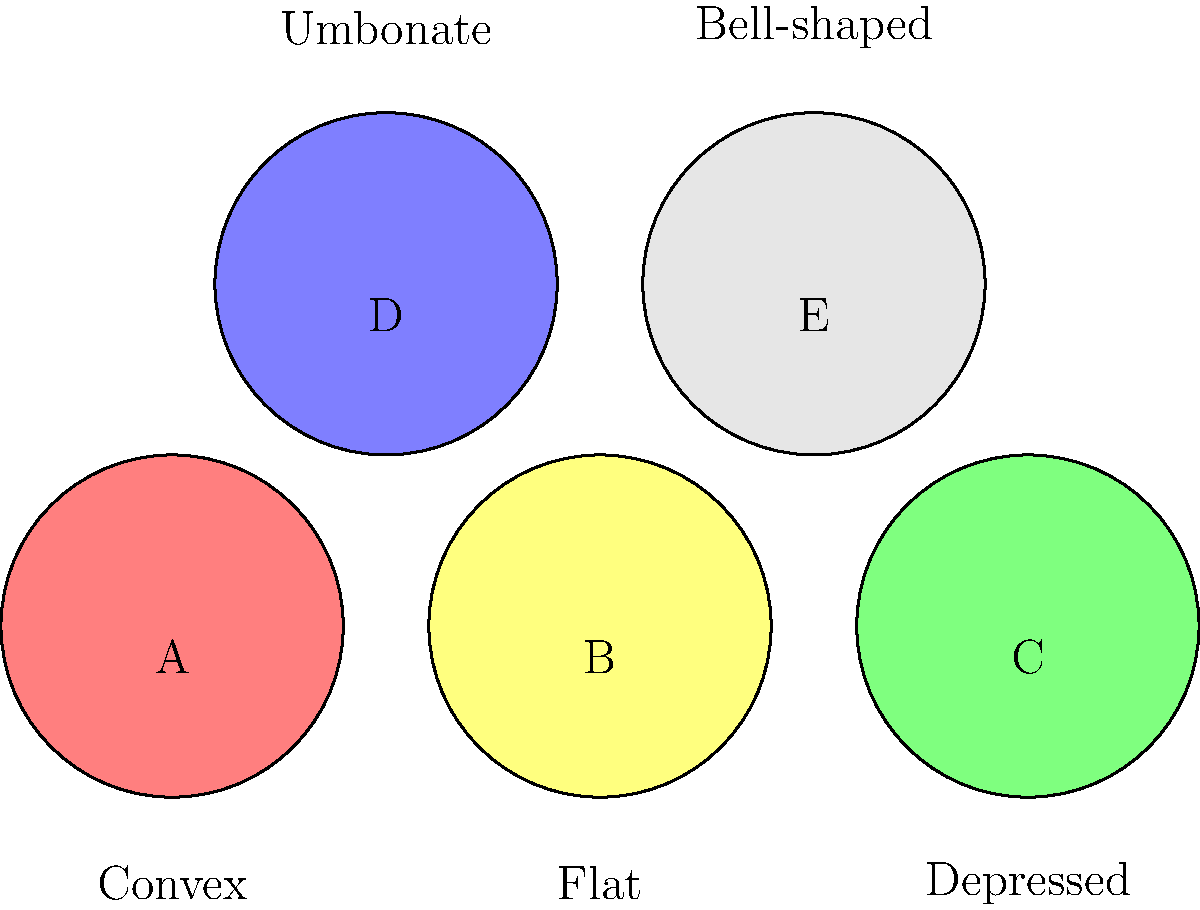As a fungi conservationist, identify the mushroom cap shape that is most likely to belong to a species in the Amanita genus, which often has a characteristic umbrella-like appearance when mature. To answer this question, let's analyze the different cap shapes presented in the image:

1. Mushroom A: Convex shape - rounded but not fully umbrella-like
2. Mushroom B: Flat shape - too horizontal to be characteristic of mature Amanita
3. Mushroom C: Depressed shape - center is sunken, unlike typical Amanita
4. Mushroom D: Umbonate shape - has a raised center, not typical for mature Amanita
5. Mushroom E: Bell-shaped - this shape is most similar to the characteristic umbrella-like appearance of mature Amanita species

The Amanita genus, when mature, often displays a cap that opens up like an umbrella. This description most closely matches the bell-shaped cap of Mushroom E. While young Amanita specimens may have more rounded or egg-shaped caps, the question asks for the most likely shape for a characteristic mature specimen.

Therefore, the bell-shaped cap (Mushroom E) is the most likely to belong to a species in the Amanita genus.
Answer: Bell-shaped (E) 